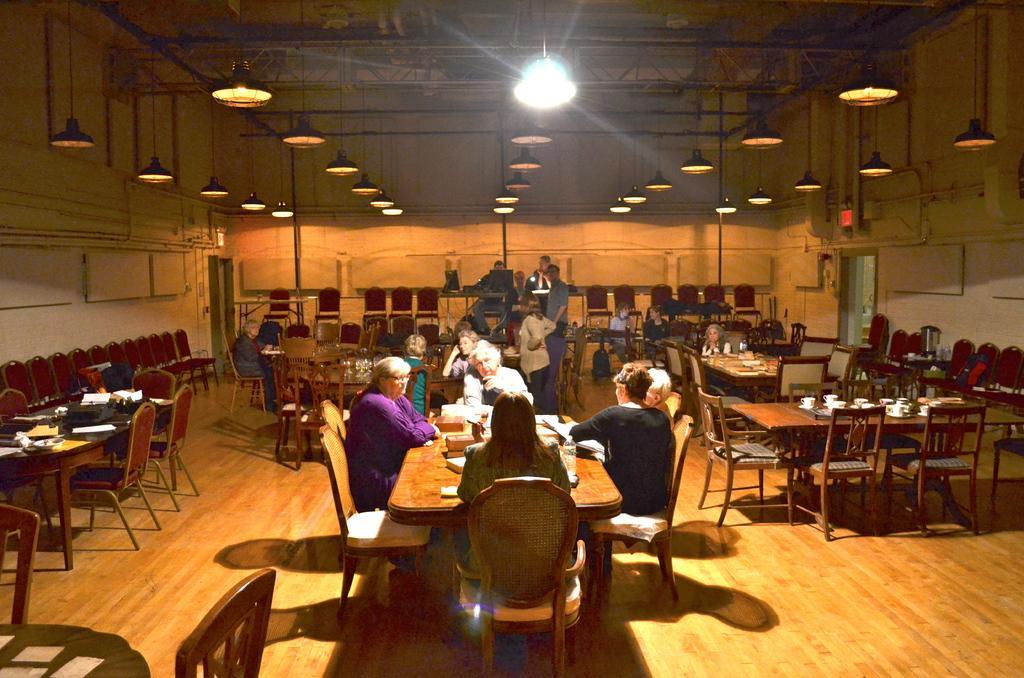In one or two sentences, can you explain what this image depicts? This picture we can see a group of people sitting and some are standing in the dining hall. On the we can see hanging a spot lights, Iron frame and shed. On the bottom we can see wooden flooring, Center we can see a dining table and three lady and on man sitting having food and discussing something. 